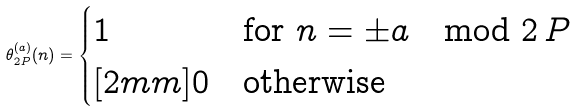<formula> <loc_0><loc_0><loc_500><loc_500>\theta _ { 2 P } ^ { ( a ) } ( n ) = \begin{cases} 1 & \text {for $n = \pm a \mod 2 \, P$} \\ [ 2 m m ] 0 & \text {otherwise} \end{cases}</formula> 